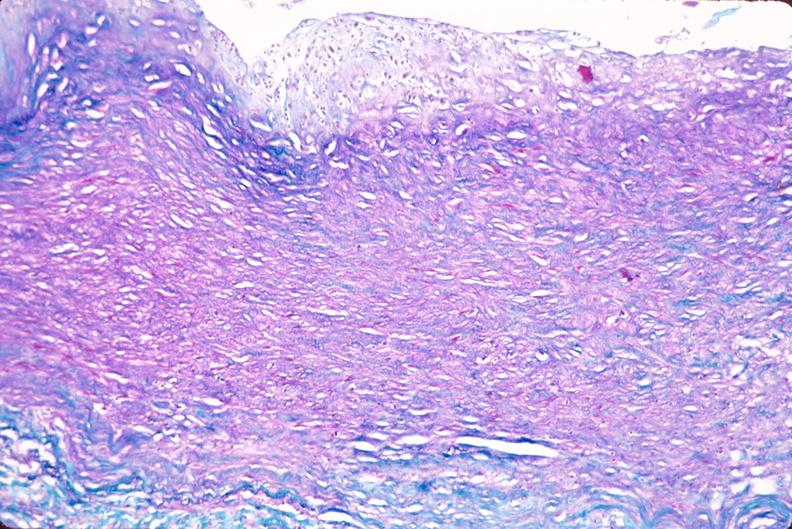what is present?
Answer the question using a single word or phrase. Vasculature 